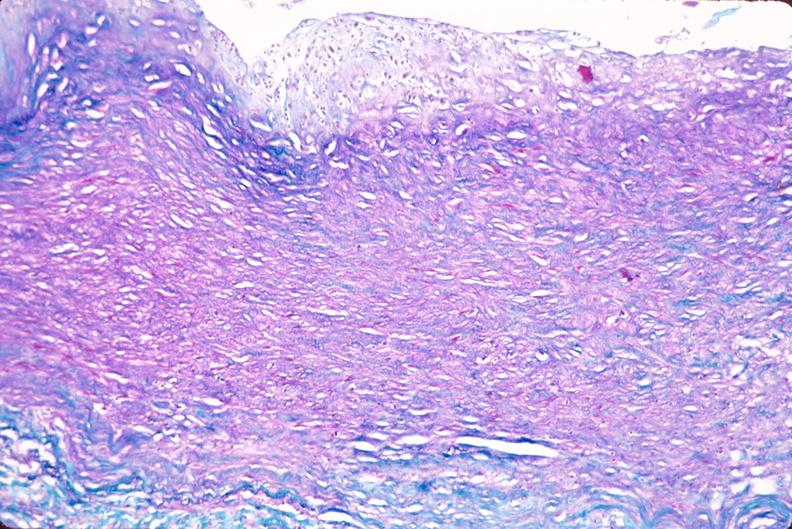what is present?
Answer the question using a single word or phrase. Vasculature 